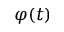Convert formula to latex. <formula><loc_0><loc_0><loc_500><loc_500>\varphi ( t )</formula> 